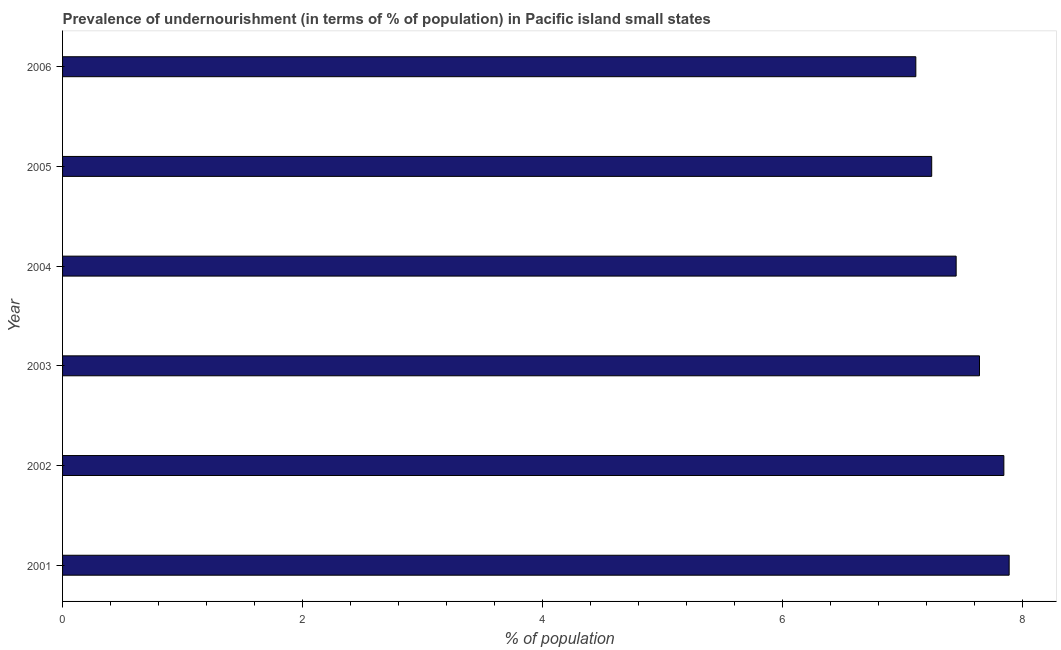Does the graph contain grids?
Your answer should be very brief. No. What is the title of the graph?
Keep it short and to the point. Prevalence of undernourishment (in terms of % of population) in Pacific island small states. What is the label or title of the X-axis?
Offer a terse response. % of population. What is the percentage of undernourished population in 2002?
Provide a short and direct response. 7.84. Across all years, what is the maximum percentage of undernourished population?
Offer a terse response. 7.89. Across all years, what is the minimum percentage of undernourished population?
Keep it short and to the point. 7.11. What is the sum of the percentage of undernourished population?
Your response must be concise. 45.17. What is the difference between the percentage of undernourished population in 2001 and 2005?
Keep it short and to the point. 0.65. What is the average percentage of undernourished population per year?
Make the answer very short. 7.53. What is the median percentage of undernourished population?
Keep it short and to the point. 7.54. What is the ratio of the percentage of undernourished population in 2001 to that in 2006?
Give a very brief answer. 1.11. Is the percentage of undernourished population in 2001 less than that in 2002?
Your answer should be very brief. No. What is the difference between the highest and the second highest percentage of undernourished population?
Your response must be concise. 0.04. Is the sum of the percentage of undernourished population in 2001 and 2005 greater than the maximum percentage of undernourished population across all years?
Your answer should be very brief. Yes. What is the difference between the highest and the lowest percentage of undernourished population?
Ensure brevity in your answer.  0.78. How many years are there in the graph?
Offer a terse response. 6. What is the difference between two consecutive major ticks on the X-axis?
Your response must be concise. 2. What is the % of population of 2001?
Provide a succinct answer. 7.89. What is the % of population of 2002?
Ensure brevity in your answer.  7.84. What is the % of population of 2003?
Your answer should be compact. 7.64. What is the % of population in 2004?
Your answer should be very brief. 7.45. What is the % of population in 2005?
Provide a succinct answer. 7.24. What is the % of population of 2006?
Give a very brief answer. 7.11. What is the difference between the % of population in 2001 and 2002?
Keep it short and to the point. 0.04. What is the difference between the % of population in 2001 and 2003?
Keep it short and to the point. 0.25. What is the difference between the % of population in 2001 and 2004?
Make the answer very short. 0.44. What is the difference between the % of population in 2001 and 2005?
Offer a very short reply. 0.65. What is the difference between the % of population in 2001 and 2006?
Give a very brief answer. 0.78. What is the difference between the % of population in 2002 and 2003?
Offer a terse response. 0.2. What is the difference between the % of population in 2002 and 2004?
Give a very brief answer. 0.4. What is the difference between the % of population in 2002 and 2005?
Make the answer very short. 0.6. What is the difference between the % of population in 2002 and 2006?
Give a very brief answer. 0.73. What is the difference between the % of population in 2003 and 2004?
Keep it short and to the point. 0.19. What is the difference between the % of population in 2003 and 2005?
Your answer should be compact. 0.4. What is the difference between the % of population in 2003 and 2006?
Offer a terse response. 0.53. What is the difference between the % of population in 2004 and 2005?
Offer a very short reply. 0.2. What is the difference between the % of population in 2004 and 2006?
Offer a very short reply. 0.34. What is the difference between the % of population in 2005 and 2006?
Ensure brevity in your answer.  0.13. What is the ratio of the % of population in 2001 to that in 2003?
Provide a succinct answer. 1.03. What is the ratio of the % of population in 2001 to that in 2004?
Give a very brief answer. 1.06. What is the ratio of the % of population in 2001 to that in 2005?
Your answer should be compact. 1.09. What is the ratio of the % of population in 2001 to that in 2006?
Make the answer very short. 1.11. What is the ratio of the % of population in 2002 to that in 2003?
Give a very brief answer. 1.03. What is the ratio of the % of population in 2002 to that in 2004?
Give a very brief answer. 1.05. What is the ratio of the % of population in 2002 to that in 2005?
Ensure brevity in your answer.  1.08. What is the ratio of the % of population in 2002 to that in 2006?
Your answer should be compact. 1.1. What is the ratio of the % of population in 2003 to that in 2004?
Your response must be concise. 1.03. What is the ratio of the % of population in 2003 to that in 2005?
Your response must be concise. 1.05. What is the ratio of the % of population in 2003 to that in 2006?
Provide a short and direct response. 1.07. What is the ratio of the % of population in 2004 to that in 2005?
Keep it short and to the point. 1.03. What is the ratio of the % of population in 2004 to that in 2006?
Provide a short and direct response. 1.05. 